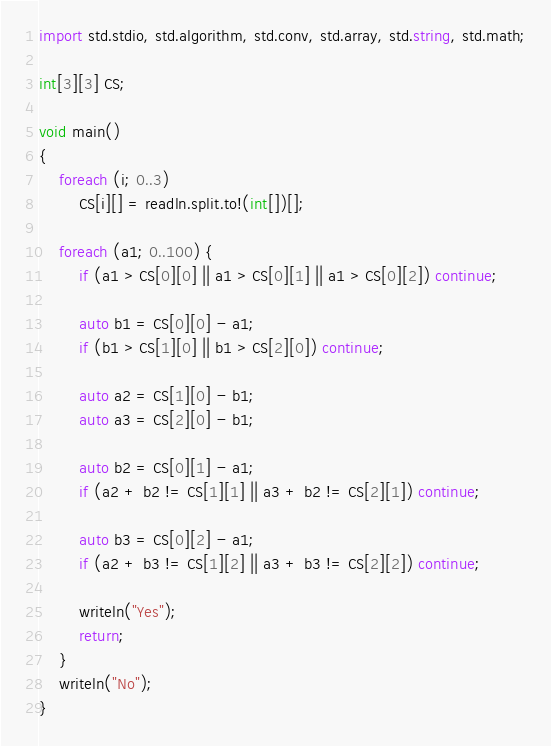Convert code to text. <code><loc_0><loc_0><loc_500><loc_500><_D_>import std.stdio, std.algorithm, std.conv, std.array, std.string, std.math;

int[3][3] CS;

void main()
{
    foreach (i; 0..3)
        CS[i][] = readln.split.to!(int[])[];

    foreach (a1; 0..100) {
        if (a1 > CS[0][0] || a1 > CS[0][1] || a1 > CS[0][2]) continue;

        auto b1 = CS[0][0] - a1;
        if (b1 > CS[1][0] || b1 > CS[2][0]) continue;

        auto a2 = CS[1][0] - b1;
        auto a3 = CS[2][0] - b1;

        auto b2 = CS[0][1] - a1;
        if (a2 + b2 != CS[1][1] || a3 + b2 != CS[2][1]) continue;

        auto b3 = CS[0][2] - a1;
        if (a2 + b3 != CS[1][2] || a3 + b3 != CS[2][2]) continue;

        writeln("Yes");
        return;
    }
    writeln("No");
}</code> 